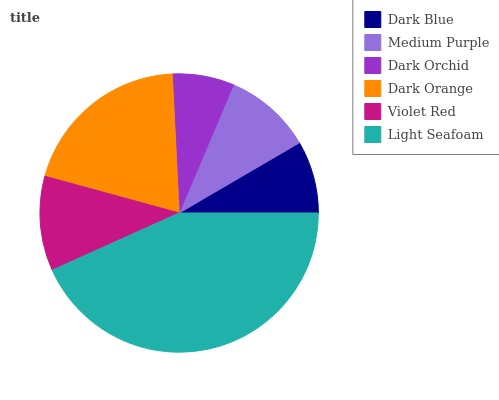Is Dark Orchid the minimum?
Answer yes or no. Yes. Is Light Seafoam the maximum?
Answer yes or no. Yes. Is Medium Purple the minimum?
Answer yes or no. No. Is Medium Purple the maximum?
Answer yes or no. No. Is Medium Purple greater than Dark Blue?
Answer yes or no. Yes. Is Dark Blue less than Medium Purple?
Answer yes or no. Yes. Is Dark Blue greater than Medium Purple?
Answer yes or no. No. Is Medium Purple less than Dark Blue?
Answer yes or no. No. Is Violet Red the high median?
Answer yes or no. Yes. Is Medium Purple the low median?
Answer yes or no. Yes. Is Dark Orange the high median?
Answer yes or no. No. Is Dark Orange the low median?
Answer yes or no. No. 